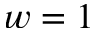<formula> <loc_0><loc_0><loc_500><loc_500>w = 1</formula> 